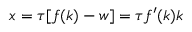Convert formula to latex. <formula><loc_0><loc_0><loc_500><loc_500>x = \tau [ f ( k ) - w ] = \tau f ^ { \prime } ( k ) k</formula> 